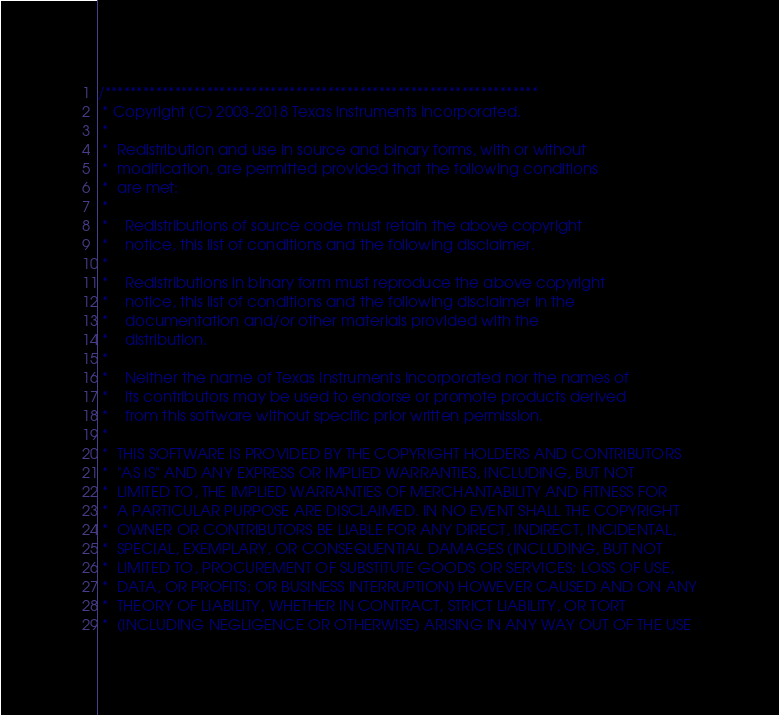Convert code to text. <code><loc_0><loc_0><loc_500><loc_500><_C_>/********************************************************************
 * Copyright (C) 2003-2018 Texas Instruments Incorporated.
 * 
 *  Redistribution and use in source and binary forms, with or without 
 *  modification, are permitted provided that the following conditions 
 *  are met:
 *
 *    Redistributions of source code must retain the above copyright 
 *    notice, this list of conditions and the following disclaimer.
 *
 *    Redistributions in binary form must reproduce the above copyright
 *    notice, this list of conditions and the following disclaimer in the 
 *    documentation and/or other materials provided with the   
 *    distribution.
 *
 *    Neither the name of Texas Instruments Incorporated nor the names of
 *    its contributors may be used to endorse or promote products derived
 *    from this software without specific prior written permission.
 *
 *  THIS SOFTWARE IS PROVIDED BY THE COPYRIGHT HOLDERS AND CONTRIBUTORS 
 *  "AS IS" AND ANY EXPRESS OR IMPLIED WARRANTIES, INCLUDING, BUT NOT 
 *  LIMITED TO, THE IMPLIED WARRANTIES OF MERCHANTABILITY AND FITNESS FOR
 *  A PARTICULAR PURPOSE ARE DISCLAIMED. IN NO EVENT SHALL THE COPYRIGHT 
 *  OWNER OR CONTRIBUTORS BE LIABLE FOR ANY DIRECT, INDIRECT, INCIDENTAL, 
 *  SPECIAL, EXEMPLARY, OR CONSEQUENTIAL DAMAGES (INCLUDING, BUT NOT 
 *  LIMITED TO, PROCUREMENT OF SUBSTITUTE GOODS OR SERVICES; LOSS OF USE,
 *  DATA, OR PROFITS; OR BUSINESS INTERRUPTION) HOWEVER CAUSED AND ON ANY
 *  THEORY OF LIABILITY, WHETHER IN CONTRACT, STRICT LIABILITY, OR TORT 
 *  (INCLUDING NEGLIGENCE OR OTHERWISE) ARISING IN ANY WAY OUT OF THE USE </code> 